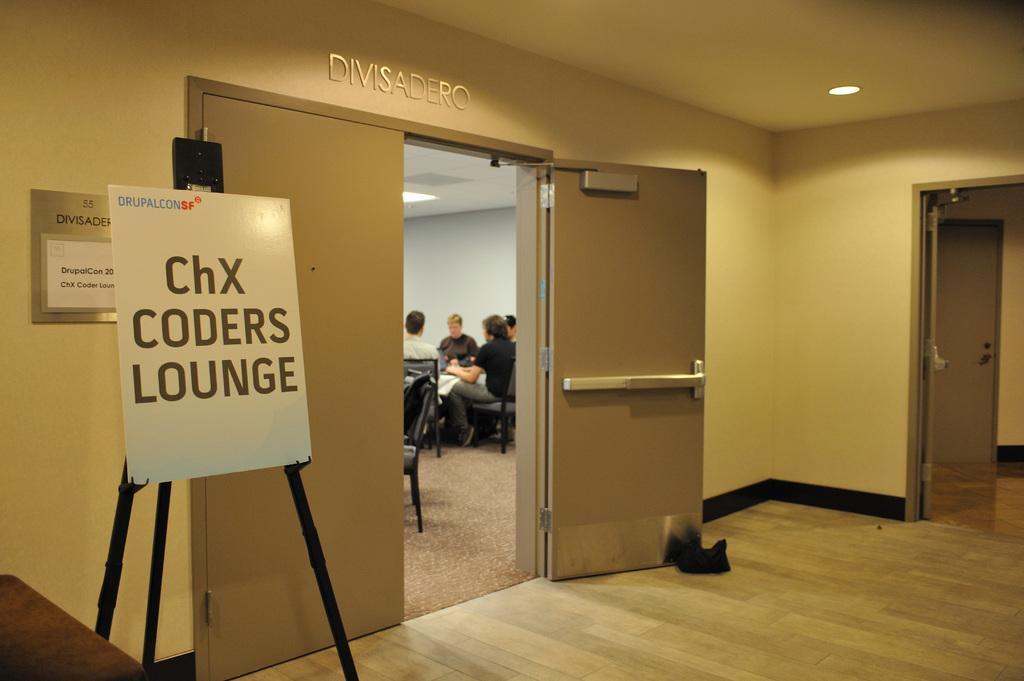Could you give a brief overview of what you see in this image? In this image I can see a white board and on it I can see something is written. In the background I can see few people are sitting on chairs. I can also see few doors. 